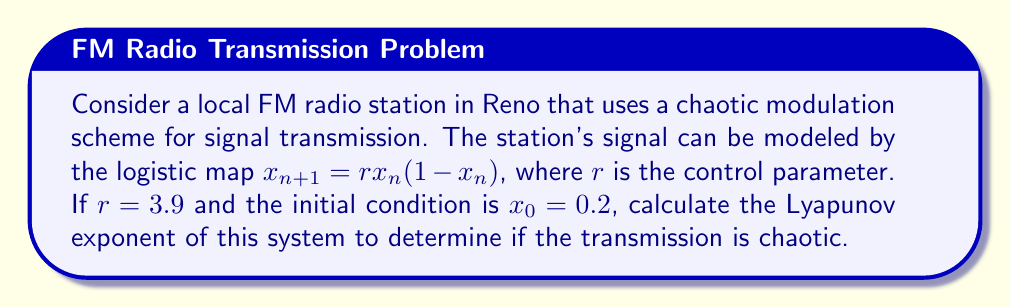Could you help me with this problem? To calculate the Lyapunov exponent for the given logistic map:

1. The formula for the Lyapunov exponent (λ) is:
   $$\lambda = \lim_{N \to \infty} \frac{1}{N} \sum_{n=0}^{N-1} \ln |f'(x_n)|$$

2. For the logistic map, $f(x) = rx(1-x)$, so $f'(x) = r(1-2x)$

3. Initialize variables:
   $r = 3.9$
   $x_0 = 0.2$
   $N = 1000$ (sufficiently large for convergence)

4. Iterate the map and sum the logarithms:
   $$\text{sum} = \sum_{n=0}^{999} \ln |3.9(1-2x_n)|$$

5. Calculate $x_n$ values using the recurrence relation:
   $x_{n+1} = 3.9x_n(1-x_n)$

6. Implement the iteration and summation (pseudocode):
   ```
   sum = 0
   x = 0.2
   for n = 0 to 999:
       sum += ln|3.9*(1-2*x)|
       x = 3.9*x*(1-x)
   ```

7. After iteration, calculate λ:
   $$\lambda = \frac{\text{sum}}{1000}$$

8. The result of this calculation gives λ ≈ 0.5635

9. Since λ > 0, the system is chaotic, indicating an unpredictable and sensitive signal transmission.
Answer: λ ≈ 0.5635 (chaotic) 